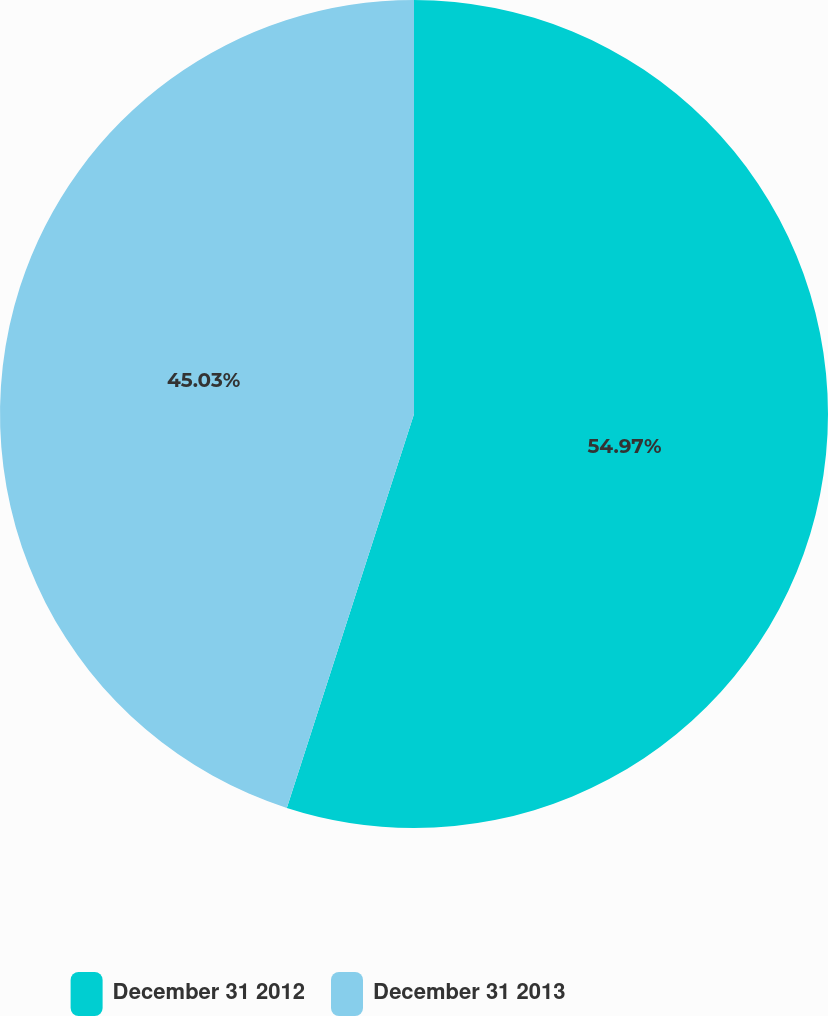Convert chart. <chart><loc_0><loc_0><loc_500><loc_500><pie_chart><fcel>December 31 2012<fcel>December 31 2013<nl><fcel>54.97%<fcel>45.03%<nl></chart> 